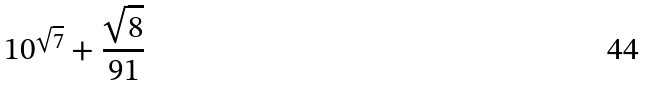<formula> <loc_0><loc_0><loc_500><loc_500>1 0 ^ { \sqrt { 7 } } + \frac { \sqrt { 8 } } { 9 1 }</formula> 